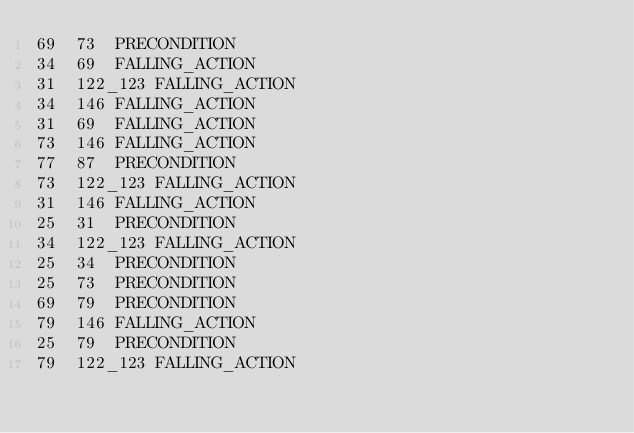Convert code to text. <code><loc_0><loc_0><loc_500><loc_500><_SQL_>69	73	PRECONDITION
34	69	FALLING_ACTION
31	122_123	FALLING_ACTION
34	146	FALLING_ACTION
31	69	FALLING_ACTION
73	146	FALLING_ACTION
77	87	PRECONDITION
73	122_123	FALLING_ACTION
31	146	FALLING_ACTION
25	31	PRECONDITION
34	122_123	FALLING_ACTION
25	34	PRECONDITION
25	73	PRECONDITION
69	79	PRECONDITION
79	146	FALLING_ACTION
25	79	PRECONDITION
79	122_123	FALLING_ACTION
</code> 